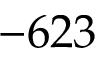<formula> <loc_0><loc_0><loc_500><loc_500>- 6 2 3</formula> 